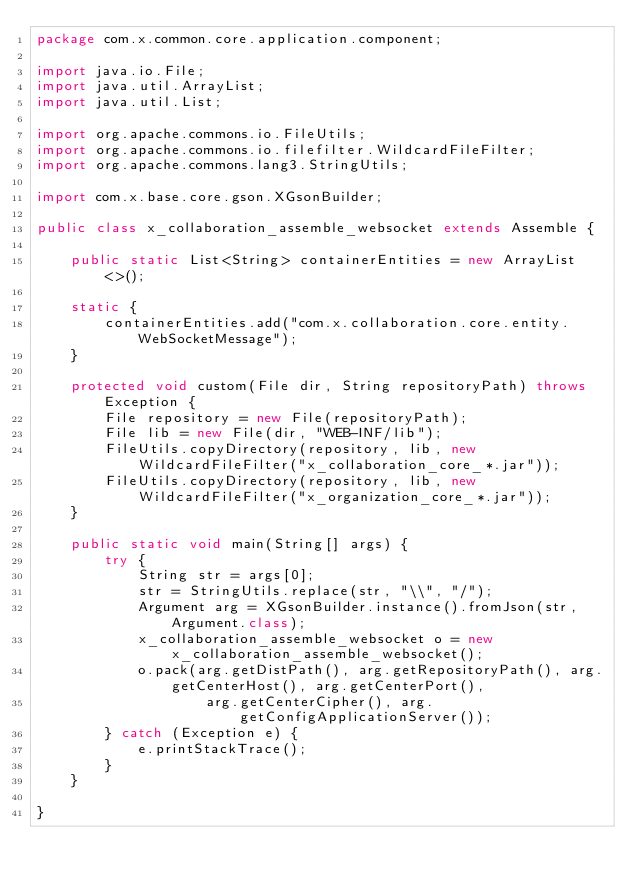<code> <loc_0><loc_0><loc_500><loc_500><_Java_>package com.x.common.core.application.component;

import java.io.File;
import java.util.ArrayList;
import java.util.List;

import org.apache.commons.io.FileUtils;
import org.apache.commons.io.filefilter.WildcardFileFilter;
import org.apache.commons.lang3.StringUtils;

import com.x.base.core.gson.XGsonBuilder;

public class x_collaboration_assemble_websocket extends Assemble {

	public static List<String> containerEntities = new ArrayList<>();

	static {
		containerEntities.add("com.x.collaboration.core.entity.WebSocketMessage");
	}

	protected void custom(File dir, String repositoryPath) throws Exception {
		File repository = new File(repositoryPath);
		File lib = new File(dir, "WEB-INF/lib");
		FileUtils.copyDirectory(repository, lib, new WildcardFileFilter("x_collaboration_core_*.jar"));
		FileUtils.copyDirectory(repository, lib, new WildcardFileFilter("x_organization_core_*.jar"));
	}

	public static void main(String[] args) {
		try {
			String str = args[0];
			str = StringUtils.replace(str, "\\", "/");
			Argument arg = XGsonBuilder.instance().fromJson(str, Argument.class);
			x_collaboration_assemble_websocket o = new x_collaboration_assemble_websocket();
			o.pack(arg.getDistPath(), arg.getRepositoryPath(), arg.getCenterHost(), arg.getCenterPort(),
					arg.getCenterCipher(), arg.getConfigApplicationServer());
		} catch (Exception e) {
			e.printStackTrace();
		}
	}

}
</code> 